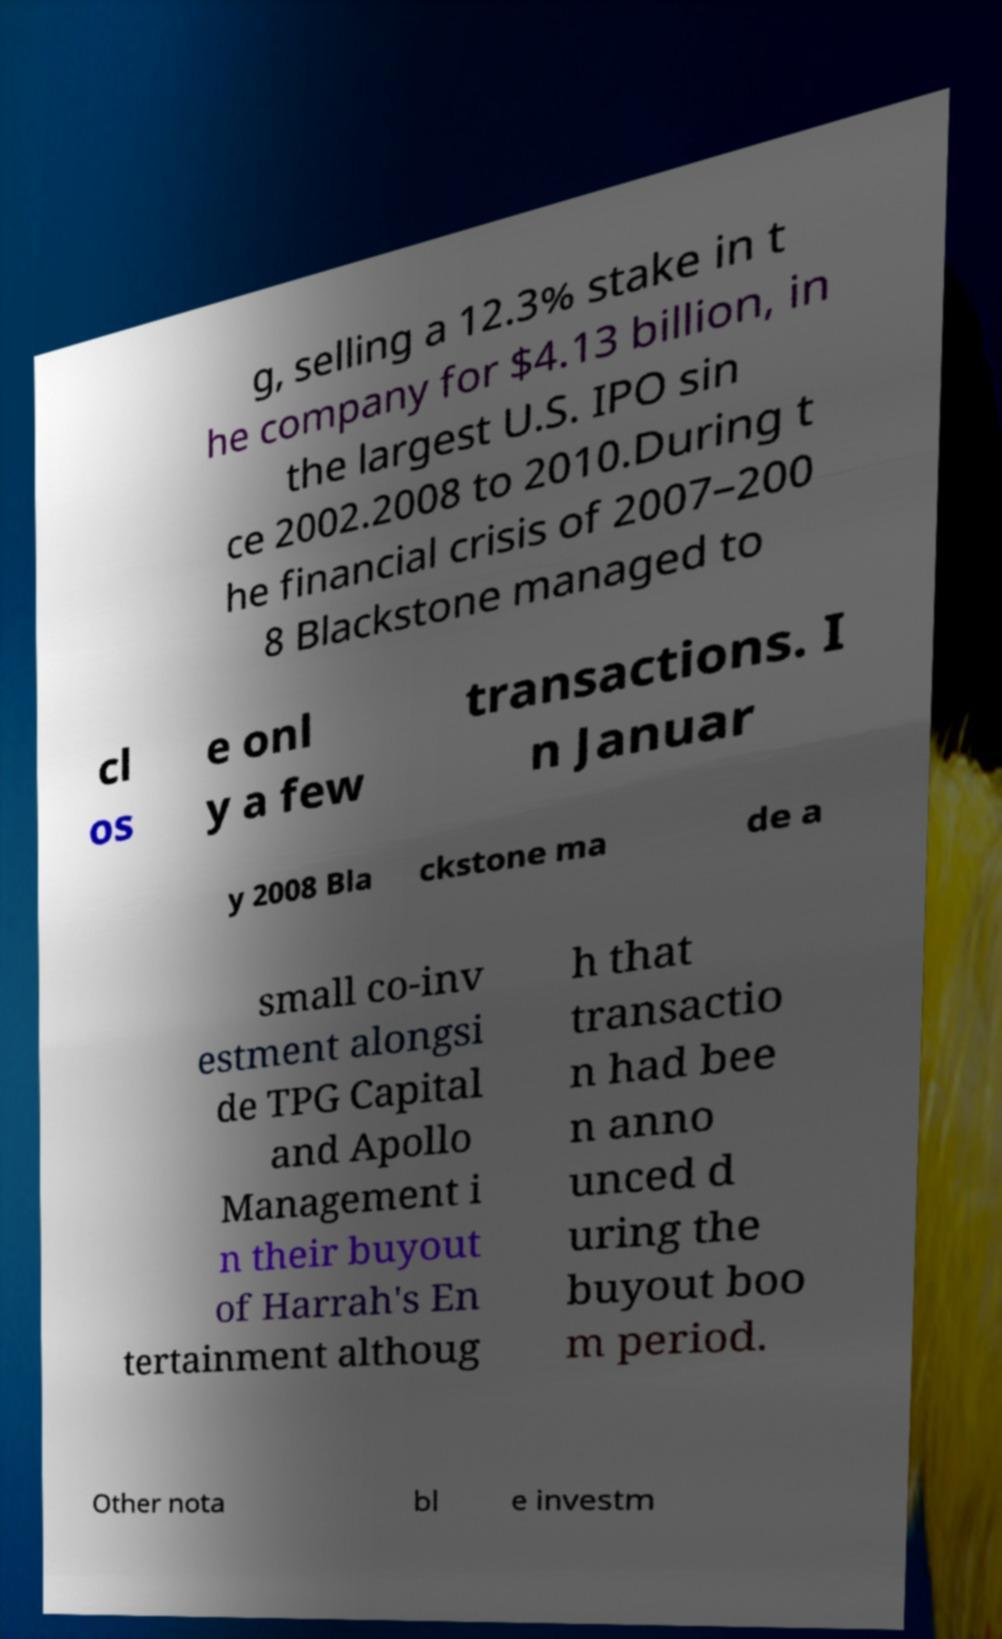Please read and relay the text visible in this image. What does it say? g, selling a 12.3% stake in t he company for $4.13 billion, in the largest U.S. IPO sin ce 2002.2008 to 2010.During t he financial crisis of 2007–200 8 Blackstone managed to cl os e onl y a few transactions. I n Januar y 2008 Bla ckstone ma de a small co-inv estment alongsi de TPG Capital and Apollo Management i n their buyout of Harrah's En tertainment althoug h that transactio n had bee n anno unced d uring the buyout boo m period. Other nota bl e investm 